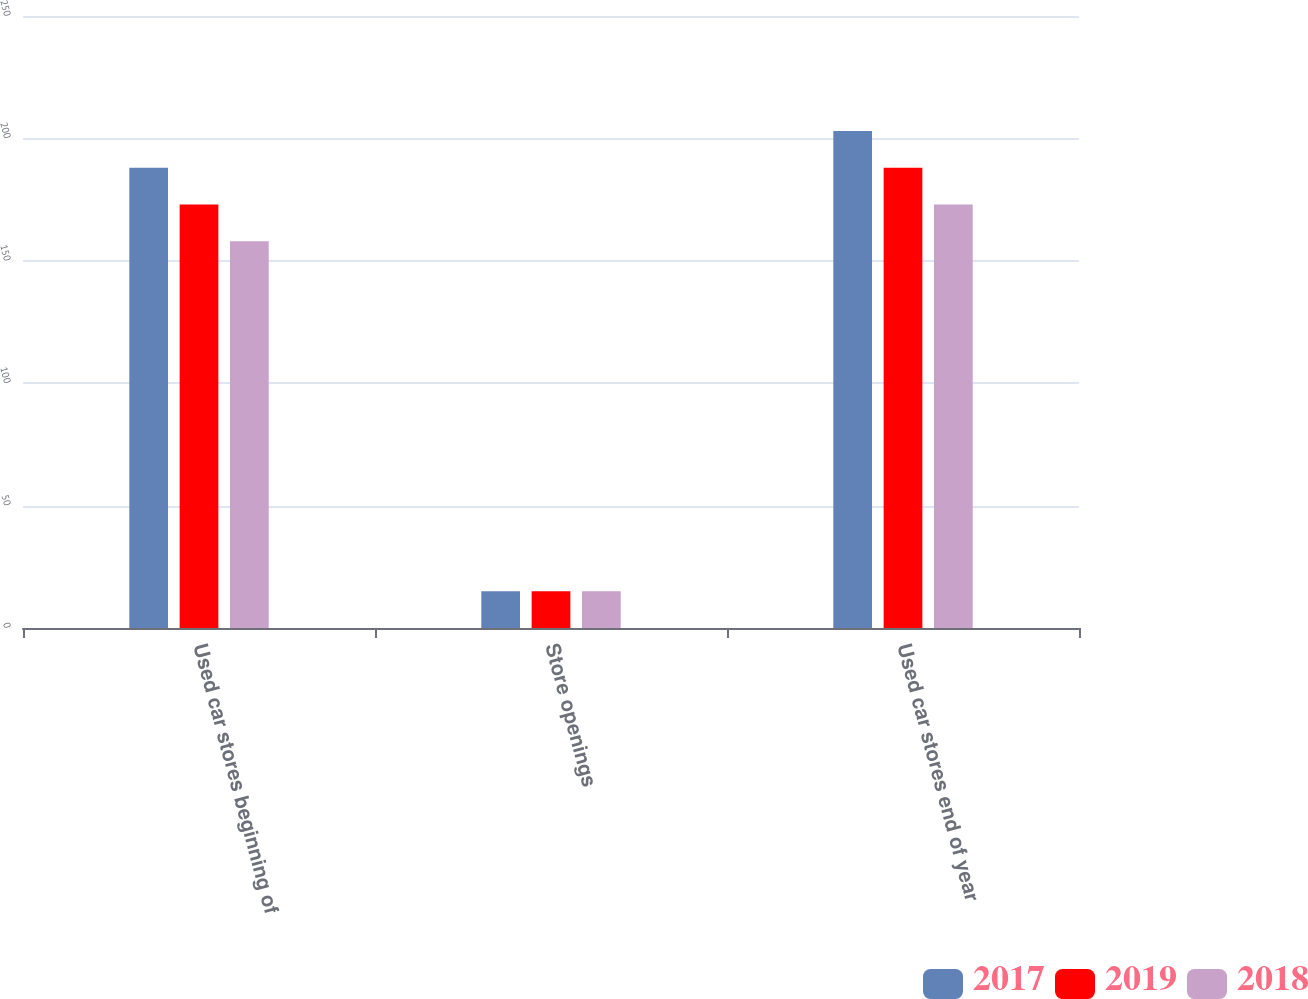Convert chart to OTSL. <chart><loc_0><loc_0><loc_500><loc_500><stacked_bar_chart><ecel><fcel>Used car stores beginning of<fcel>Store openings<fcel>Used car stores end of year<nl><fcel>2017<fcel>188<fcel>15<fcel>203<nl><fcel>2019<fcel>173<fcel>15<fcel>188<nl><fcel>2018<fcel>158<fcel>15<fcel>173<nl></chart> 